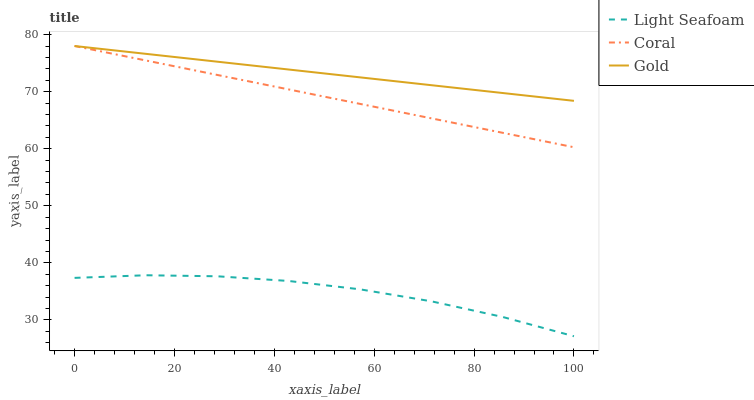Does Light Seafoam have the minimum area under the curve?
Answer yes or no. Yes. Does Gold have the maximum area under the curve?
Answer yes or no. Yes. Does Gold have the minimum area under the curve?
Answer yes or no. No. Does Light Seafoam have the maximum area under the curve?
Answer yes or no. No. Is Coral the smoothest?
Answer yes or no. Yes. Is Light Seafoam the roughest?
Answer yes or no. Yes. Is Gold the smoothest?
Answer yes or no. No. Is Gold the roughest?
Answer yes or no. No. Does Light Seafoam have the lowest value?
Answer yes or no. Yes. Does Gold have the lowest value?
Answer yes or no. No. Does Gold have the highest value?
Answer yes or no. Yes. Does Light Seafoam have the highest value?
Answer yes or no. No. Is Light Seafoam less than Gold?
Answer yes or no. Yes. Is Gold greater than Light Seafoam?
Answer yes or no. Yes. Does Gold intersect Coral?
Answer yes or no. Yes. Is Gold less than Coral?
Answer yes or no. No. Is Gold greater than Coral?
Answer yes or no. No. Does Light Seafoam intersect Gold?
Answer yes or no. No. 